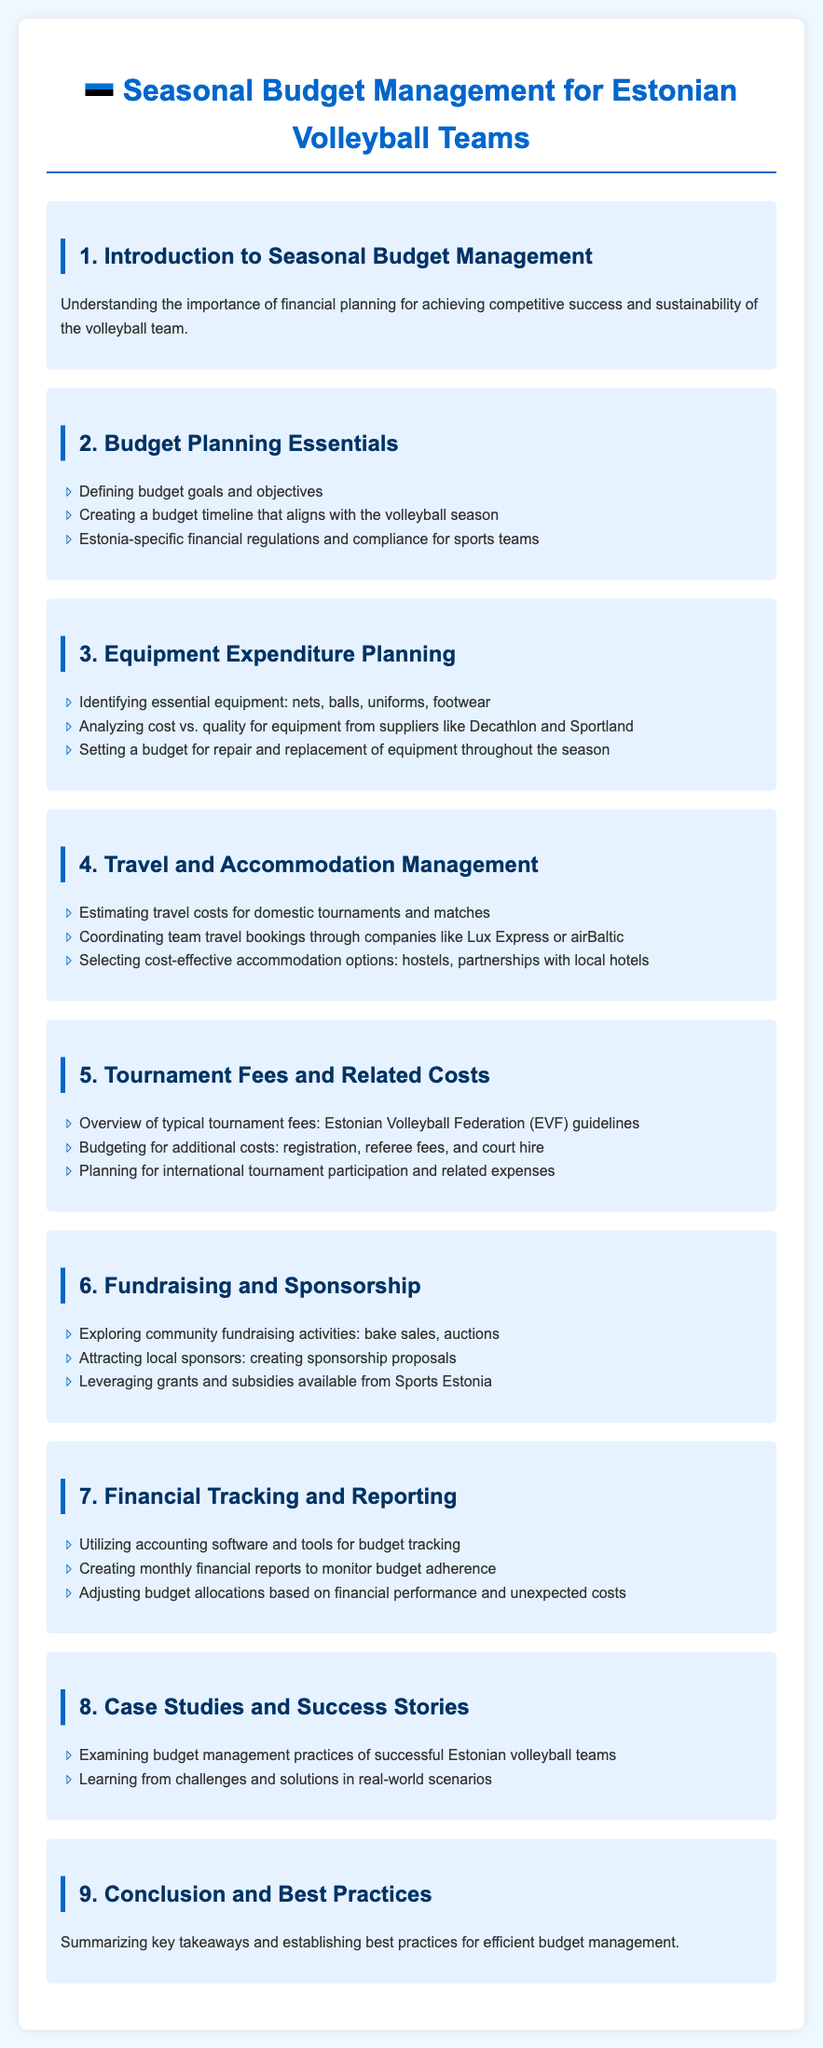what is the title of the syllabus? The title of the syllabus is provided at the head of the document, specifying the subject matter.
Answer: Seasonal Budget Management for Estonian Volleyball Teams what is the focus of module 3? Module 3 outlines specific financial planning related to equipment expenditures, detailing what needs to be considered for budgeting.
Answer: Equipment Expenditure Planning which companies are mentioned for travel bookings? This is a specific point mentioned in module 4 regarding travel management, highlighting potential partners for bookings.
Answer: Lux Express or airBaltic how many modules are in the syllabus? The total number of modules gives an idea of the breadth of content covered in the syllabus.
Answer: 9 what is a fundraising activity mentioned in module 6? This highlights a type of community involvement in financing, as presented in the document.
Answer: bake sales what is a key element in financial tracking according to module 7? This focuses on one of the critical practices for managing a budget effectively as stated in the syllabus.
Answer: accounting software what is the aim of module 1? The aim of module 1 gives insight into the overall intent of the syllabus regarding financial planning.
Answer: Understanding the importance of financial planning which organization's guidelines are referred to in module 5? This refers to the authority that provides the framework and rules for budgeting related to tournaments.
Answer: Estonian Volleyball Federation (EVF) 